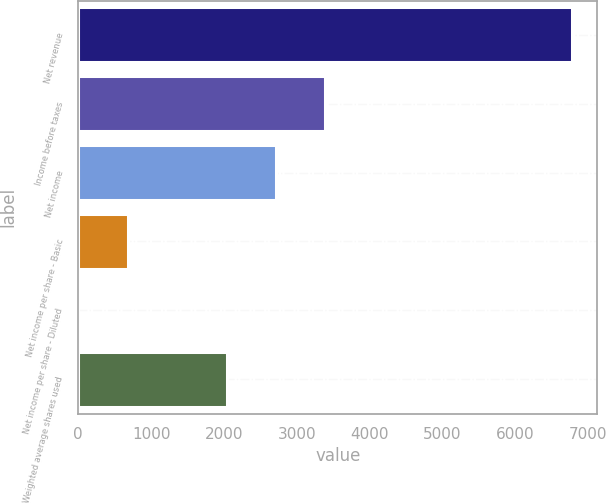Convert chart to OTSL. <chart><loc_0><loc_0><loc_500><loc_500><bar_chart><fcel>Net revenue<fcel>Income before taxes<fcel>Net income<fcel>Net income per share - Basic<fcel>Net income per share - Diluted<fcel>Weighted average shares used<nl><fcel>6782<fcel>3392.05<fcel>2714.06<fcel>680.09<fcel>2.1<fcel>2036.07<nl></chart> 